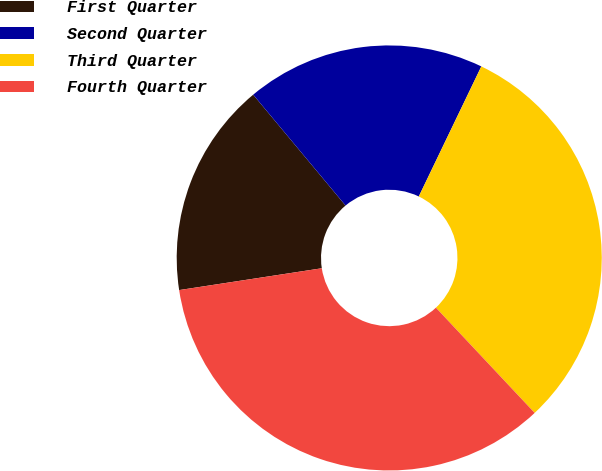<chart> <loc_0><loc_0><loc_500><loc_500><pie_chart><fcel>First Quarter<fcel>Second Quarter<fcel>Third Quarter<fcel>Fourth Quarter<nl><fcel>16.36%<fcel>18.19%<fcel>30.87%<fcel>34.58%<nl></chart> 